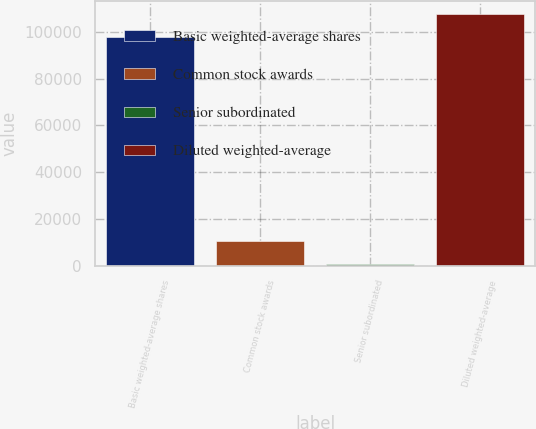<chart> <loc_0><loc_0><loc_500><loc_500><bar_chart><fcel>Basic weighted-average shares<fcel>Common stock awards<fcel>Senior subordinated<fcel>Diluted weighted-average<nl><fcel>97702<fcel>10690.2<fcel>816<fcel>107576<nl></chart> 